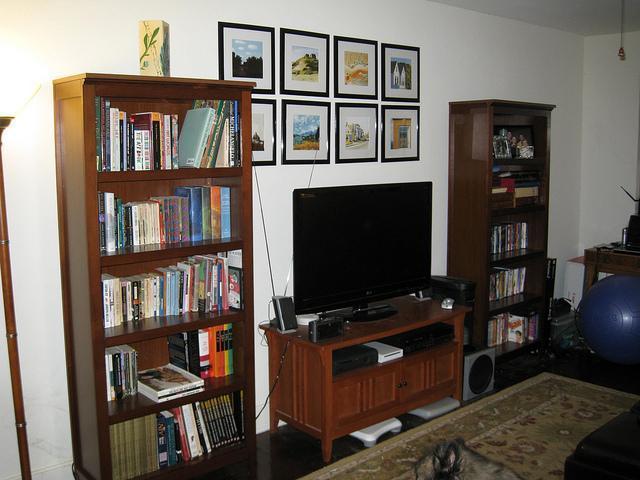How many books can be seen?
Give a very brief answer. 2. How many people are wearing a hat in the picture?
Give a very brief answer. 0. 